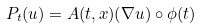Convert formula to latex. <formula><loc_0><loc_0><loc_500><loc_500>P _ { t } ( u ) = A ( t , x ) ( \nabla u ) \circ \phi ( t )</formula> 